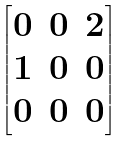Convert formula to latex. <formula><loc_0><loc_0><loc_500><loc_500>\begin{bmatrix} 0 & 0 & 2 \\ 1 & 0 & 0 \\ 0 & 0 & 0 \end{bmatrix}</formula> 